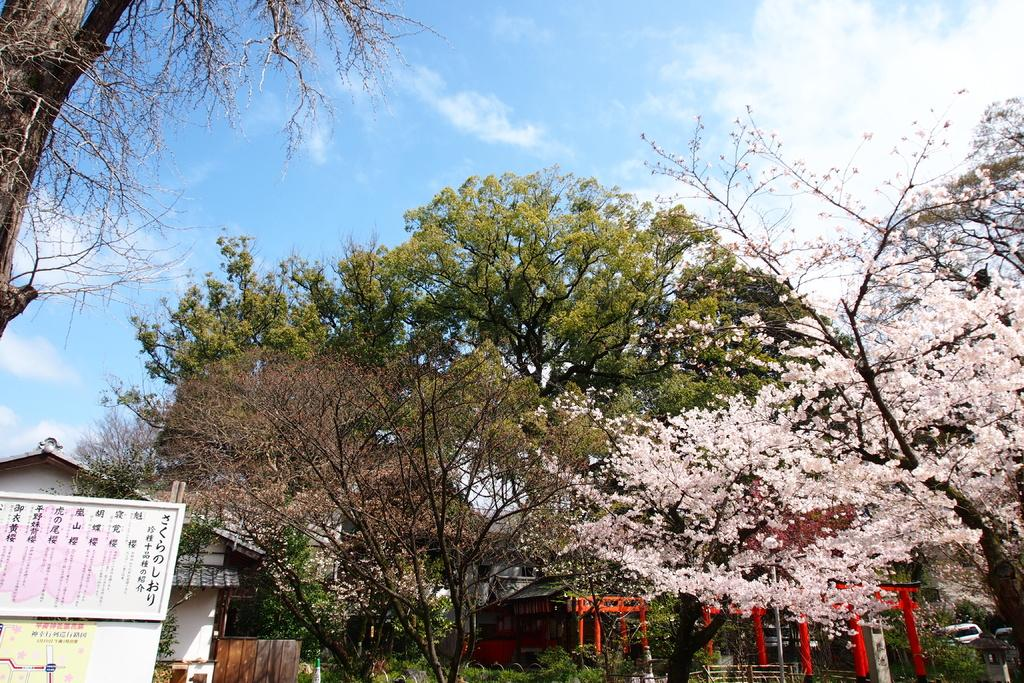What type of structures can be seen in the image? There are buildings in the image. What is on the board that is visible in the image? There is a board with writing in the image. What type of vegetation is present in the image? There are trees in the image. What can be seen in the background of the image? The sky is visible in the background of the image. What is the condition of the sky in the image? The sky appears to be clear in the image. How many clovers can be seen growing near the buildings in the image? There are no clovers visible in the image; it features buildings, a board with writing, trees, and a clear sky. What type of pie is being served at the event depicted in the image? There is no event or pie present in the image. 